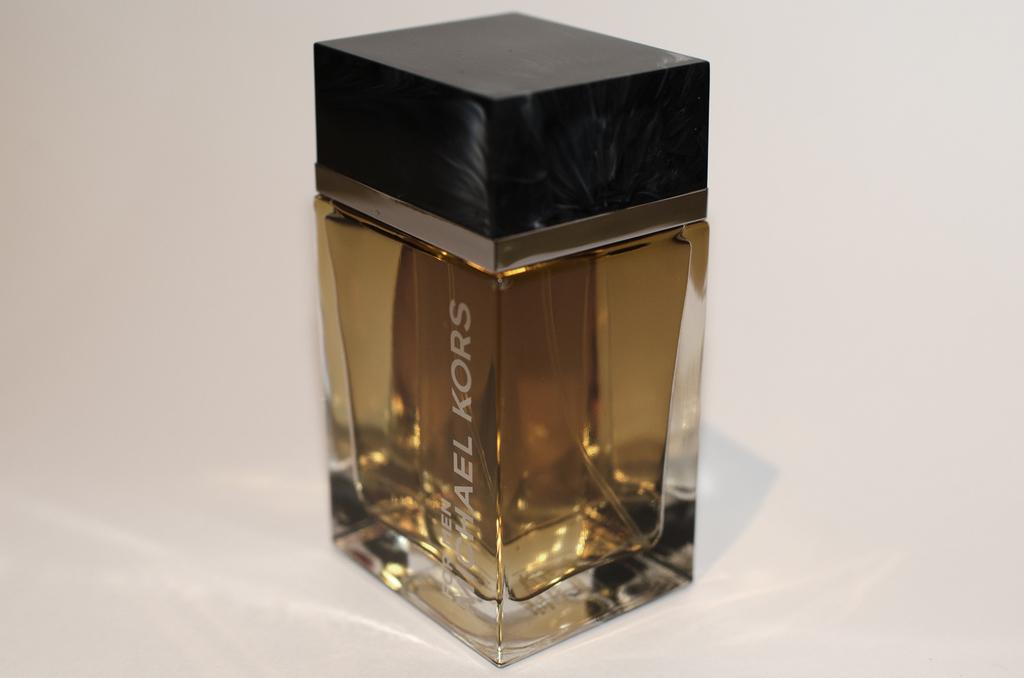Who makes this perfume?
Give a very brief answer. Michael kors. 